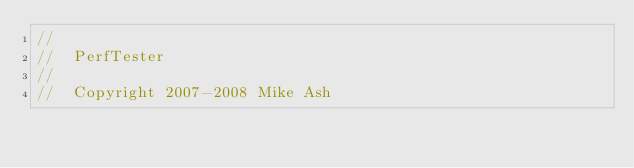Convert code to text. <code><loc_0><loc_0><loc_500><loc_500><_ObjectiveC_>//
//  PerfTester
//
//  Copyright 2007-2008 Mike Ash</code> 